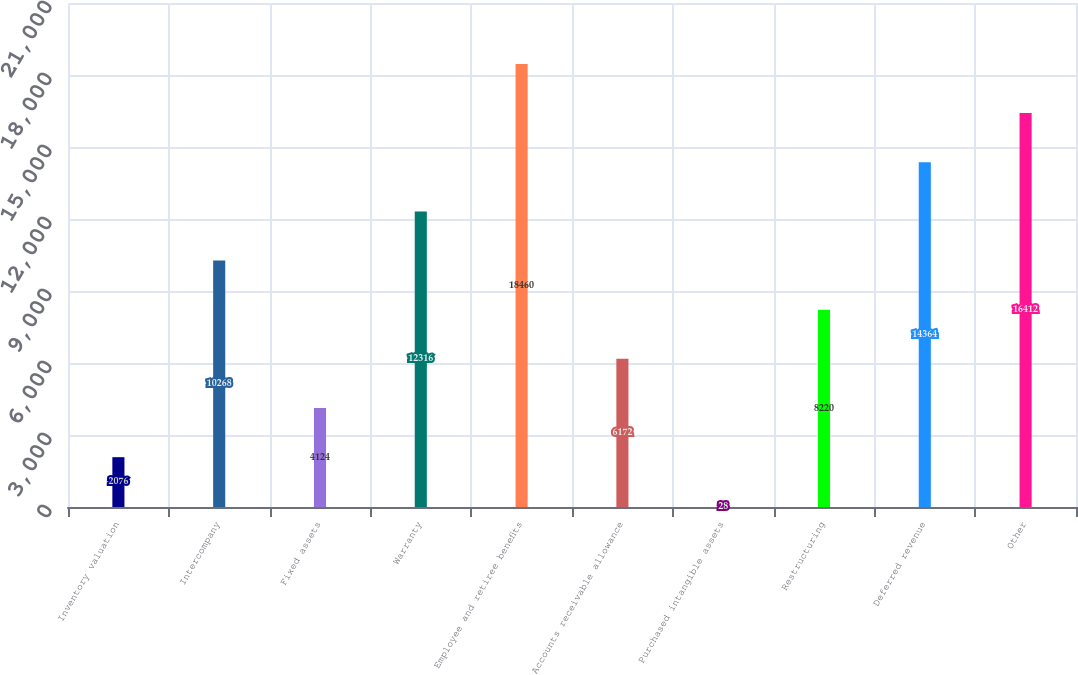<chart> <loc_0><loc_0><loc_500><loc_500><bar_chart><fcel>Inventory valuation<fcel>Intercompany<fcel>Fixed assets<fcel>Warranty<fcel>Employee and retiree benefits<fcel>Accounts receivable allowance<fcel>Purchased intangible assets<fcel>Restructuring<fcel>Deferred revenue<fcel>Other<nl><fcel>2076<fcel>10268<fcel>4124<fcel>12316<fcel>18460<fcel>6172<fcel>28<fcel>8220<fcel>14364<fcel>16412<nl></chart> 